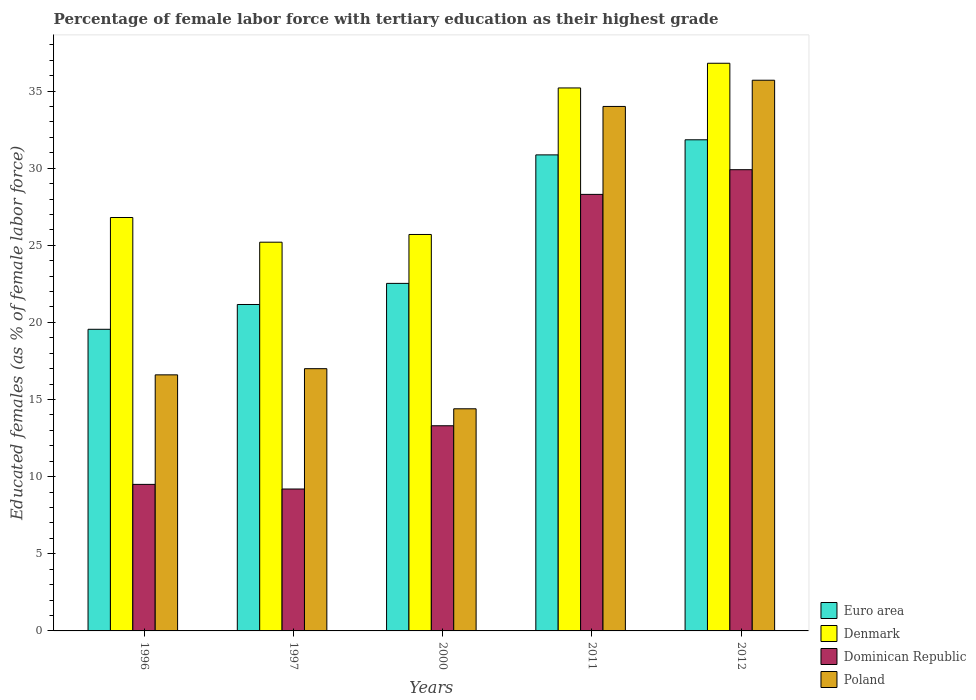How many different coloured bars are there?
Keep it short and to the point. 4. How many bars are there on the 1st tick from the left?
Your answer should be very brief. 4. How many bars are there on the 5th tick from the right?
Give a very brief answer. 4. What is the percentage of female labor force with tertiary education in Dominican Republic in 1997?
Provide a short and direct response. 9.2. Across all years, what is the maximum percentage of female labor force with tertiary education in Poland?
Give a very brief answer. 35.7. Across all years, what is the minimum percentage of female labor force with tertiary education in Euro area?
Your response must be concise. 19.55. In which year was the percentage of female labor force with tertiary education in Dominican Republic minimum?
Your response must be concise. 1997. What is the total percentage of female labor force with tertiary education in Dominican Republic in the graph?
Offer a terse response. 90.2. What is the difference between the percentage of female labor force with tertiary education in Dominican Republic in 1997 and that in 2012?
Your answer should be very brief. -20.7. What is the difference between the percentage of female labor force with tertiary education in Euro area in 2011 and the percentage of female labor force with tertiary education in Denmark in 2012?
Your answer should be very brief. -5.94. What is the average percentage of female labor force with tertiary education in Denmark per year?
Ensure brevity in your answer.  29.94. In the year 1997, what is the difference between the percentage of female labor force with tertiary education in Denmark and percentage of female labor force with tertiary education in Poland?
Provide a succinct answer. 8.2. In how many years, is the percentage of female labor force with tertiary education in Poland greater than 26 %?
Give a very brief answer. 2. What is the ratio of the percentage of female labor force with tertiary education in Denmark in 2000 to that in 2012?
Keep it short and to the point. 0.7. Is the percentage of female labor force with tertiary education in Poland in 1997 less than that in 2012?
Offer a terse response. Yes. Is the difference between the percentage of female labor force with tertiary education in Denmark in 2000 and 2012 greater than the difference between the percentage of female labor force with tertiary education in Poland in 2000 and 2012?
Provide a short and direct response. Yes. What is the difference between the highest and the second highest percentage of female labor force with tertiary education in Denmark?
Provide a succinct answer. 1.6. What is the difference between the highest and the lowest percentage of female labor force with tertiary education in Denmark?
Ensure brevity in your answer.  11.6. Is it the case that in every year, the sum of the percentage of female labor force with tertiary education in Euro area and percentage of female labor force with tertiary education in Denmark is greater than the sum of percentage of female labor force with tertiary education in Poland and percentage of female labor force with tertiary education in Dominican Republic?
Give a very brief answer. No. What does the 2nd bar from the left in 1996 represents?
Provide a succinct answer. Denmark. What does the 2nd bar from the right in 2000 represents?
Make the answer very short. Dominican Republic. How many years are there in the graph?
Your answer should be very brief. 5. Are the values on the major ticks of Y-axis written in scientific E-notation?
Give a very brief answer. No. Does the graph contain any zero values?
Offer a very short reply. No. Where does the legend appear in the graph?
Offer a terse response. Bottom right. How many legend labels are there?
Your answer should be very brief. 4. How are the legend labels stacked?
Your answer should be compact. Vertical. What is the title of the graph?
Provide a succinct answer. Percentage of female labor force with tertiary education as their highest grade. What is the label or title of the X-axis?
Make the answer very short. Years. What is the label or title of the Y-axis?
Provide a short and direct response. Educated females (as % of female labor force). What is the Educated females (as % of female labor force) of Euro area in 1996?
Ensure brevity in your answer.  19.55. What is the Educated females (as % of female labor force) in Denmark in 1996?
Make the answer very short. 26.8. What is the Educated females (as % of female labor force) of Poland in 1996?
Offer a very short reply. 16.6. What is the Educated females (as % of female labor force) of Euro area in 1997?
Your answer should be very brief. 21.16. What is the Educated females (as % of female labor force) of Denmark in 1997?
Your response must be concise. 25.2. What is the Educated females (as % of female labor force) of Dominican Republic in 1997?
Offer a terse response. 9.2. What is the Educated females (as % of female labor force) in Poland in 1997?
Give a very brief answer. 17. What is the Educated females (as % of female labor force) in Euro area in 2000?
Offer a very short reply. 22.53. What is the Educated females (as % of female labor force) of Denmark in 2000?
Give a very brief answer. 25.7. What is the Educated females (as % of female labor force) in Dominican Republic in 2000?
Offer a very short reply. 13.3. What is the Educated females (as % of female labor force) in Poland in 2000?
Your response must be concise. 14.4. What is the Educated females (as % of female labor force) in Euro area in 2011?
Offer a very short reply. 30.86. What is the Educated females (as % of female labor force) of Denmark in 2011?
Your answer should be compact. 35.2. What is the Educated females (as % of female labor force) in Dominican Republic in 2011?
Your answer should be very brief. 28.3. What is the Educated females (as % of female labor force) in Euro area in 2012?
Provide a succinct answer. 31.84. What is the Educated females (as % of female labor force) in Denmark in 2012?
Keep it short and to the point. 36.8. What is the Educated females (as % of female labor force) in Dominican Republic in 2012?
Provide a succinct answer. 29.9. What is the Educated females (as % of female labor force) in Poland in 2012?
Provide a succinct answer. 35.7. Across all years, what is the maximum Educated females (as % of female labor force) in Euro area?
Provide a short and direct response. 31.84. Across all years, what is the maximum Educated females (as % of female labor force) in Denmark?
Give a very brief answer. 36.8. Across all years, what is the maximum Educated females (as % of female labor force) in Dominican Republic?
Offer a very short reply. 29.9. Across all years, what is the maximum Educated females (as % of female labor force) of Poland?
Your response must be concise. 35.7. Across all years, what is the minimum Educated females (as % of female labor force) of Euro area?
Keep it short and to the point. 19.55. Across all years, what is the minimum Educated females (as % of female labor force) of Denmark?
Provide a short and direct response. 25.2. Across all years, what is the minimum Educated females (as % of female labor force) of Dominican Republic?
Your response must be concise. 9.2. Across all years, what is the minimum Educated females (as % of female labor force) of Poland?
Provide a short and direct response. 14.4. What is the total Educated females (as % of female labor force) of Euro area in the graph?
Provide a succinct answer. 125.94. What is the total Educated females (as % of female labor force) in Denmark in the graph?
Provide a succinct answer. 149.7. What is the total Educated females (as % of female labor force) of Dominican Republic in the graph?
Your response must be concise. 90.2. What is the total Educated females (as % of female labor force) in Poland in the graph?
Your answer should be compact. 117.7. What is the difference between the Educated females (as % of female labor force) of Euro area in 1996 and that in 1997?
Your answer should be compact. -1.61. What is the difference between the Educated females (as % of female labor force) in Dominican Republic in 1996 and that in 1997?
Make the answer very short. 0.3. What is the difference between the Educated females (as % of female labor force) in Poland in 1996 and that in 1997?
Offer a very short reply. -0.4. What is the difference between the Educated females (as % of female labor force) of Euro area in 1996 and that in 2000?
Keep it short and to the point. -2.98. What is the difference between the Educated females (as % of female labor force) in Denmark in 1996 and that in 2000?
Provide a short and direct response. 1.1. What is the difference between the Educated females (as % of female labor force) of Euro area in 1996 and that in 2011?
Provide a succinct answer. -11.31. What is the difference between the Educated females (as % of female labor force) in Denmark in 1996 and that in 2011?
Ensure brevity in your answer.  -8.4. What is the difference between the Educated females (as % of female labor force) in Dominican Republic in 1996 and that in 2011?
Ensure brevity in your answer.  -18.8. What is the difference between the Educated females (as % of female labor force) in Poland in 1996 and that in 2011?
Offer a very short reply. -17.4. What is the difference between the Educated females (as % of female labor force) in Euro area in 1996 and that in 2012?
Your answer should be very brief. -12.29. What is the difference between the Educated females (as % of female labor force) of Denmark in 1996 and that in 2012?
Give a very brief answer. -10. What is the difference between the Educated females (as % of female labor force) in Dominican Republic in 1996 and that in 2012?
Provide a succinct answer. -20.4. What is the difference between the Educated females (as % of female labor force) in Poland in 1996 and that in 2012?
Your answer should be compact. -19.1. What is the difference between the Educated females (as % of female labor force) in Euro area in 1997 and that in 2000?
Give a very brief answer. -1.37. What is the difference between the Educated females (as % of female labor force) of Dominican Republic in 1997 and that in 2000?
Ensure brevity in your answer.  -4.1. What is the difference between the Educated females (as % of female labor force) of Euro area in 1997 and that in 2011?
Keep it short and to the point. -9.7. What is the difference between the Educated females (as % of female labor force) in Dominican Republic in 1997 and that in 2011?
Provide a short and direct response. -19.1. What is the difference between the Educated females (as % of female labor force) in Poland in 1997 and that in 2011?
Offer a very short reply. -17. What is the difference between the Educated females (as % of female labor force) of Euro area in 1997 and that in 2012?
Your answer should be compact. -10.68. What is the difference between the Educated females (as % of female labor force) in Dominican Republic in 1997 and that in 2012?
Offer a terse response. -20.7. What is the difference between the Educated females (as % of female labor force) in Poland in 1997 and that in 2012?
Provide a short and direct response. -18.7. What is the difference between the Educated females (as % of female labor force) in Euro area in 2000 and that in 2011?
Your answer should be very brief. -8.33. What is the difference between the Educated females (as % of female labor force) of Denmark in 2000 and that in 2011?
Your response must be concise. -9.5. What is the difference between the Educated females (as % of female labor force) in Dominican Republic in 2000 and that in 2011?
Keep it short and to the point. -15. What is the difference between the Educated females (as % of female labor force) in Poland in 2000 and that in 2011?
Provide a succinct answer. -19.6. What is the difference between the Educated females (as % of female labor force) in Euro area in 2000 and that in 2012?
Give a very brief answer. -9.31. What is the difference between the Educated females (as % of female labor force) of Dominican Republic in 2000 and that in 2012?
Provide a short and direct response. -16.6. What is the difference between the Educated females (as % of female labor force) of Poland in 2000 and that in 2012?
Provide a succinct answer. -21.3. What is the difference between the Educated females (as % of female labor force) of Euro area in 2011 and that in 2012?
Give a very brief answer. -0.98. What is the difference between the Educated females (as % of female labor force) in Denmark in 2011 and that in 2012?
Your answer should be very brief. -1.6. What is the difference between the Educated females (as % of female labor force) in Dominican Republic in 2011 and that in 2012?
Keep it short and to the point. -1.6. What is the difference between the Educated females (as % of female labor force) of Poland in 2011 and that in 2012?
Keep it short and to the point. -1.7. What is the difference between the Educated females (as % of female labor force) of Euro area in 1996 and the Educated females (as % of female labor force) of Denmark in 1997?
Keep it short and to the point. -5.65. What is the difference between the Educated females (as % of female labor force) of Euro area in 1996 and the Educated females (as % of female labor force) of Dominican Republic in 1997?
Offer a very short reply. 10.35. What is the difference between the Educated females (as % of female labor force) in Euro area in 1996 and the Educated females (as % of female labor force) in Poland in 1997?
Your answer should be very brief. 2.55. What is the difference between the Educated females (as % of female labor force) of Denmark in 1996 and the Educated females (as % of female labor force) of Poland in 1997?
Make the answer very short. 9.8. What is the difference between the Educated females (as % of female labor force) of Euro area in 1996 and the Educated females (as % of female labor force) of Denmark in 2000?
Keep it short and to the point. -6.15. What is the difference between the Educated females (as % of female labor force) of Euro area in 1996 and the Educated females (as % of female labor force) of Dominican Republic in 2000?
Make the answer very short. 6.25. What is the difference between the Educated females (as % of female labor force) of Euro area in 1996 and the Educated females (as % of female labor force) of Poland in 2000?
Provide a short and direct response. 5.15. What is the difference between the Educated females (as % of female labor force) of Euro area in 1996 and the Educated females (as % of female labor force) of Denmark in 2011?
Ensure brevity in your answer.  -15.65. What is the difference between the Educated females (as % of female labor force) in Euro area in 1996 and the Educated females (as % of female labor force) in Dominican Republic in 2011?
Provide a short and direct response. -8.75. What is the difference between the Educated females (as % of female labor force) of Euro area in 1996 and the Educated females (as % of female labor force) of Poland in 2011?
Make the answer very short. -14.45. What is the difference between the Educated females (as % of female labor force) in Denmark in 1996 and the Educated females (as % of female labor force) in Dominican Republic in 2011?
Make the answer very short. -1.5. What is the difference between the Educated females (as % of female labor force) of Denmark in 1996 and the Educated females (as % of female labor force) of Poland in 2011?
Keep it short and to the point. -7.2. What is the difference between the Educated females (as % of female labor force) of Dominican Republic in 1996 and the Educated females (as % of female labor force) of Poland in 2011?
Your answer should be very brief. -24.5. What is the difference between the Educated females (as % of female labor force) of Euro area in 1996 and the Educated females (as % of female labor force) of Denmark in 2012?
Your response must be concise. -17.25. What is the difference between the Educated females (as % of female labor force) of Euro area in 1996 and the Educated females (as % of female labor force) of Dominican Republic in 2012?
Your answer should be very brief. -10.35. What is the difference between the Educated females (as % of female labor force) in Euro area in 1996 and the Educated females (as % of female labor force) in Poland in 2012?
Keep it short and to the point. -16.15. What is the difference between the Educated females (as % of female labor force) of Denmark in 1996 and the Educated females (as % of female labor force) of Dominican Republic in 2012?
Offer a terse response. -3.1. What is the difference between the Educated females (as % of female labor force) of Denmark in 1996 and the Educated females (as % of female labor force) of Poland in 2012?
Your answer should be very brief. -8.9. What is the difference between the Educated females (as % of female labor force) in Dominican Republic in 1996 and the Educated females (as % of female labor force) in Poland in 2012?
Give a very brief answer. -26.2. What is the difference between the Educated females (as % of female labor force) in Euro area in 1997 and the Educated females (as % of female labor force) in Denmark in 2000?
Your answer should be compact. -4.54. What is the difference between the Educated females (as % of female labor force) in Euro area in 1997 and the Educated females (as % of female labor force) in Dominican Republic in 2000?
Your answer should be very brief. 7.86. What is the difference between the Educated females (as % of female labor force) in Euro area in 1997 and the Educated females (as % of female labor force) in Poland in 2000?
Give a very brief answer. 6.76. What is the difference between the Educated females (as % of female labor force) in Denmark in 1997 and the Educated females (as % of female labor force) in Dominican Republic in 2000?
Your response must be concise. 11.9. What is the difference between the Educated females (as % of female labor force) of Denmark in 1997 and the Educated females (as % of female labor force) of Poland in 2000?
Offer a terse response. 10.8. What is the difference between the Educated females (as % of female labor force) of Dominican Republic in 1997 and the Educated females (as % of female labor force) of Poland in 2000?
Provide a short and direct response. -5.2. What is the difference between the Educated females (as % of female labor force) of Euro area in 1997 and the Educated females (as % of female labor force) of Denmark in 2011?
Your answer should be very brief. -14.04. What is the difference between the Educated females (as % of female labor force) in Euro area in 1997 and the Educated females (as % of female labor force) in Dominican Republic in 2011?
Your answer should be compact. -7.14. What is the difference between the Educated females (as % of female labor force) in Euro area in 1997 and the Educated females (as % of female labor force) in Poland in 2011?
Offer a terse response. -12.84. What is the difference between the Educated females (as % of female labor force) in Denmark in 1997 and the Educated females (as % of female labor force) in Poland in 2011?
Your response must be concise. -8.8. What is the difference between the Educated females (as % of female labor force) in Dominican Republic in 1997 and the Educated females (as % of female labor force) in Poland in 2011?
Make the answer very short. -24.8. What is the difference between the Educated females (as % of female labor force) of Euro area in 1997 and the Educated females (as % of female labor force) of Denmark in 2012?
Your response must be concise. -15.64. What is the difference between the Educated females (as % of female labor force) in Euro area in 1997 and the Educated females (as % of female labor force) in Dominican Republic in 2012?
Ensure brevity in your answer.  -8.74. What is the difference between the Educated females (as % of female labor force) of Euro area in 1997 and the Educated females (as % of female labor force) of Poland in 2012?
Your answer should be very brief. -14.54. What is the difference between the Educated females (as % of female labor force) in Denmark in 1997 and the Educated females (as % of female labor force) in Poland in 2012?
Give a very brief answer. -10.5. What is the difference between the Educated females (as % of female labor force) of Dominican Republic in 1997 and the Educated females (as % of female labor force) of Poland in 2012?
Ensure brevity in your answer.  -26.5. What is the difference between the Educated females (as % of female labor force) of Euro area in 2000 and the Educated females (as % of female labor force) of Denmark in 2011?
Provide a succinct answer. -12.67. What is the difference between the Educated females (as % of female labor force) in Euro area in 2000 and the Educated females (as % of female labor force) in Dominican Republic in 2011?
Provide a short and direct response. -5.77. What is the difference between the Educated females (as % of female labor force) of Euro area in 2000 and the Educated females (as % of female labor force) of Poland in 2011?
Make the answer very short. -11.47. What is the difference between the Educated females (as % of female labor force) in Dominican Republic in 2000 and the Educated females (as % of female labor force) in Poland in 2011?
Ensure brevity in your answer.  -20.7. What is the difference between the Educated females (as % of female labor force) of Euro area in 2000 and the Educated females (as % of female labor force) of Denmark in 2012?
Your answer should be very brief. -14.27. What is the difference between the Educated females (as % of female labor force) of Euro area in 2000 and the Educated females (as % of female labor force) of Dominican Republic in 2012?
Your response must be concise. -7.37. What is the difference between the Educated females (as % of female labor force) of Euro area in 2000 and the Educated females (as % of female labor force) of Poland in 2012?
Give a very brief answer. -13.17. What is the difference between the Educated females (as % of female labor force) in Dominican Republic in 2000 and the Educated females (as % of female labor force) in Poland in 2012?
Keep it short and to the point. -22.4. What is the difference between the Educated females (as % of female labor force) of Euro area in 2011 and the Educated females (as % of female labor force) of Denmark in 2012?
Make the answer very short. -5.94. What is the difference between the Educated females (as % of female labor force) of Euro area in 2011 and the Educated females (as % of female labor force) of Dominican Republic in 2012?
Make the answer very short. 0.96. What is the difference between the Educated females (as % of female labor force) of Euro area in 2011 and the Educated females (as % of female labor force) of Poland in 2012?
Offer a very short reply. -4.84. What is the difference between the Educated females (as % of female labor force) in Denmark in 2011 and the Educated females (as % of female labor force) in Dominican Republic in 2012?
Your answer should be compact. 5.3. What is the average Educated females (as % of female labor force) in Euro area per year?
Provide a succinct answer. 25.19. What is the average Educated females (as % of female labor force) of Denmark per year?
Ensure brevity in your answer.  29.94. What is the average Educated females (as % of female labor force) in Dominican Republic per year?
Offer a terse response. 18.04. What is the average Educated females (as % of female labor force) in Poland per year?
Provide a succinct answer. 23.54. In the year 1996, what is the difference between the Educated females (as % of female labor force) of Euro area and Educated females (as % of female labor force) of Denmark?
Provide a succinct answer. -7.25. In the year 1996, what is the difference between the Educated females (as % of female labor force) of Euro area and Educated females (as % of female labor force) of Dominican Republic?
Your response must be concise. 10.05. In the year 1996, what is the difference between the Educated females (as % of female labor force) of Euro area and Educated females (as % of female labor force) of Poland?
Your response must be concise. 2.95. In the year 1997, what is the difference between the Educated females (as % of female labor force) in Euro area and Educated females (as % of female labor force) in Denmark?
Keep it short and to the point. -4.04. In the year 1997, what is the difference between the Educated females (as % of female labor force) in Euro area and Educated females (as % of female labor force) in Dominican Republic?
Your answer should be very brief. 11.96. In the year 1997, what is the difference between the Educated females (as % of female labor force) in Euro area and Educated females (as % of female labor force) in Poland?
Ensure brevity in your answer.  4.16. In the year 1997, what is the difference between the Educated females (as % of female labor force) in Denmark and Educated females (as % of female labor force) in Dominican Republic?
Make the answer very short. 16. In the year 1997, what is the difference between the Educated females (as % of female labor force) in Dominican Republic and Educated females (as % of female labor force) in Poland?
Make the answer very short. -7.8. In the year 2000, what is the difference between the Educated females (as % of female labor force) of Euro area and Educated females (as % of female labor force) of Denmark?
Offer a terse response. -3.17. In the year 2000, what is the difference between the Educated females (as % of female labor force) in Euro area and Educated females (as % of female labor force) in Dominican Republic?
Your response must be concise. 9.23. In the year 2000, what is the difference between the Educated females (as % of female labor force) in Euro area and Educated females (as % of female labor force) in Poland?
Offer a terse response. 8.13. In the year 2000, what is the difference between the Educated females (as % of female labor force) in Dominican Republic and Educated females (as % of female labor force) in Poland?
Offer a terse response. -1.1. In the year 2011, what is the difference between the Educated females (as % of female labor force) in Euro area and Educated females (as % of female labor force) in Denmark?
Your answer should be compact. -4.34. In the year 2011, what is the difference between the Educated females (as % of female labor force) of Euro area and Educated females (as % of female labor force) of Dominican Republic?
Keep it short and to the point. 2.56. In the year 2011, what is the difference between the Educated females (as % of female labor force) of Euro area and Educated females (as % of female labor force) of Poland?
Offer a terse response. -3.14. In the year 2011, what is the difference between the Educated females (as % of female labor force) of Denmark and Educated females (as % of female labor force) of Dominican Republic?
Provide a succinct answer. 6.9. In the year 2011, what is the difference between the Educated females (as % of female labor force) of Denmark and Educated females (as % of female labor force) of Poland?
Offer a very short reply. 1.2. In the year 2012, what is the difference between the Educated females (as % of female labor force) of Euro area and Educated females (as % of female labor force) of Denmark?
Your response must be concise. -4.96. In the year 2012, what is the difference between the Educated females (as % of female labor force) in Euro area and Educated females (as % of female labor force) in Dominican Republic?
Ensure brevity in your answer.  1.94. In the year 2012, what is the difference between the Educated females (as % of female labor force) in Euro area and Educated females (as % of female labor force) in Poland?
Ensure brevity in your answer.  -3.86. In the year 2012, what is the difference between the Educated females (as % of female labor force) of Denmark and Educated females (as % of female labor force) of Dominican Republic?
Provide a succinct answer. 6.9. In the year 2012, what is the difference between the Educated females (as % of female labor force) in Dominican Republic and Educated females (as % of female labor force) in Poland?
Keep it short and to the point. -5.8. What is the ratio of the Educated females (as % of female labor force) in Euro area in 1996 to that in 1997?
Keep it short and to the point. 0.92. What is the ratio of the Educated females (as % of female labor force) in Denmark in 1996 to that in 1997?
Your answer should be very brief. 1.06. What is the ratio of the Educated females (as % of female labor force) of Dominican Republic in 1996 to that in 1997?
Provide a short and direct response. 1.03. What is the ratio of the Educated females (as % of female labor force) of Poland in 1996 to that in 1997?
Offer a terse response. 0.98. What is the ratio of the Educated females (as % of female labor force) of Euro area in 1996 to that in 2000?
Provide a short and direct response. 0.87. What is the ratio of the Educated females (as % of female labor force) of Denmark in 1996 to that in 2000?
Ensure brevity in your answer.  1.04. What is the ratio of the Educated females (as % of female labor force) in Poland in 1996 to that in 2000?
Your answer should be very brief. 1.15. What is the ratio of the Educated females (as % of female labor force) in Euro area in 1996 to that in 2011?
Keep it short and to the point. 0.63. What is the ratio of the Educated females (as % of female labor force) in Denmark in 1996 to that in 2011?
Offer a terse response. 0.76. What is the ratio of the Educated females (as % of female labor force) of Dominican Republic in 1996 to that in 2011?
Provide a short and direct response. 0.34. What is the ratio of the Educated females (as % of female labor force) of Poland in 1996 to that in 2011?
Give a very brief answer. 0.49. What is the ratio of the Educated females (as % of female labor force) of Euro area in 1996 to that in 2012?
Offer a very short reply. 0.61. What is the ratio of the Educated females (as % of female labor force) in Denmark in 1996 to that in 2012?
Offer a very short reply. 0.73. What is the ratio of the Educated females (as % of female labor force) in Dominican Republic in 1996 to that in 2012?
Keep it short and to the point. 0.32. What is the ratio of the Educated females (as % of female labor force) of Poland in 1996 to that in 2012?
Provide a succinct answer. 0.47. What is the ratio of the Educated females (as % of female labor force) in Euro area in 1997 to that in 2000?
Provide a succinct answer. 0.94. What is the ratio of the Educated females (as % of female labor force) of Denmark in 1997 to that in 2000?
Ensure brevity in your answer.  0.98. What is the ratio of the Educated females (as % of female labor force) in Dominican Republic in 1997 to that in 2000?
Your answer should be very brief. 0.69. What is the ratio of the Educated females (as % of female labor force) in Poland in 1997 to that in 2000?
Your answer should be very brief. 1.18. What is the ratio of the Educated females (as % of female labor force) of Euro area in 1997 to that in 2011?
Keep it short and to the point. 0.69. What is the ratio of the Educated females (as % of female labor force) in Denmark in 1997 to that in 2011?
Provide a short and direct response. 0.72. What is the ratio of the Educated females (as % of female labor force) in Dominican Republic in 1997 to that in 2011?
Keep it short and to the point. 0.33. What is the ratio of the Educated females (as % of female labor force) in Euro area in 1997 to that in 2012?
Give a very brief answer. 0.66. What is the ratio of the Educated females (as % of female labor force) in Denmark in 1997 to that in 2012?
Offer a terse response. 0.68. What is the ratio of the Educated females (as % of female labor force) of Dominican Republic in 1997 to that in 2012?
Make the answer very short. 0.31. What is the ratio of the Educated females (as % of female labor force) of Poland in 1997 to that in 2012?
Offer a very short reply. 0.48. What is the ratio of the Educated females (as % of female labor force) of Euro area in 2000 to that in 2011?
Offer a very short reply. 0.73. What is the ratio of the Educated females (as % of female labor force) in Denmark in 2000 to that in 2011?
Your response must be concise. 0.73. What is the ratio of the Educated females (as % of female labor force) in Dominican Republic in 2000 to that in 2011?
Offer a very short reply. 0.47. What is the ratio of the Educated females (as % of female labor force) in Poland in 2000 to that in 2011?
Offer a very short reply. 0.42. What is the ratio of the Educated females (as % of female labor force) in Euro area in 2000 to that in 2012?
Give a very brief answer. 0.71. What is the ratio of the Educated females (as % of female labor force) in Denmark in 2000 to that in 2012?
Your answer should be very brief. 0.7. What is the ratio of the Educated females (as % of female labor force) of Dominican Republic in 2000 to that in 2012?
Your answer should be very brief. 0.44. What is the ratio of the Educated females (as % of female labor force) in Poland in 2000 to that in 2012?
Your response must be concise. 0.4. What is the ratio of the Educated females (as % of female labor force) of Euro area in 2011 to that in 2012?
Provide a short and direct response. 0.97. What is the ratio of the Educated females (as % of female labor force) of Denmark in 2011 to that in 2012?
Ensure brevity in your answer.  0.96. What is the ratio of the Educated females (as % of female labor force) in Dominican Republic in 2011 to that in 2012?
Your response must be concise. 0.95. What is the difference between the highest and the second highest Educated females (as % of female labor force) in Euro area?
Your answer should be very brief. 0.98. What is the difference between the highest and the second highest Educated females (as % of female labor force) in Dominican Republic?
Give a very brief answer. 1.6. What is the difference between the highest and the second highest Educated females (as % of female labor force) in Poland?
Offer a very short reply. 1.7. What is the difference between the highest and the lowest Educated females (as % of female labor force) in Euro area?
Your answer should be very brief. 12.29. What is the difference between the highest and the lowest Educated females (as % of female labor force) in Dominican Republic?
Offer a very short reply. 20.7. What is the difference between the highest and the lowest Educated females (as % of female labor force) of Poland?
Provide a short and direct response. 21.3. 